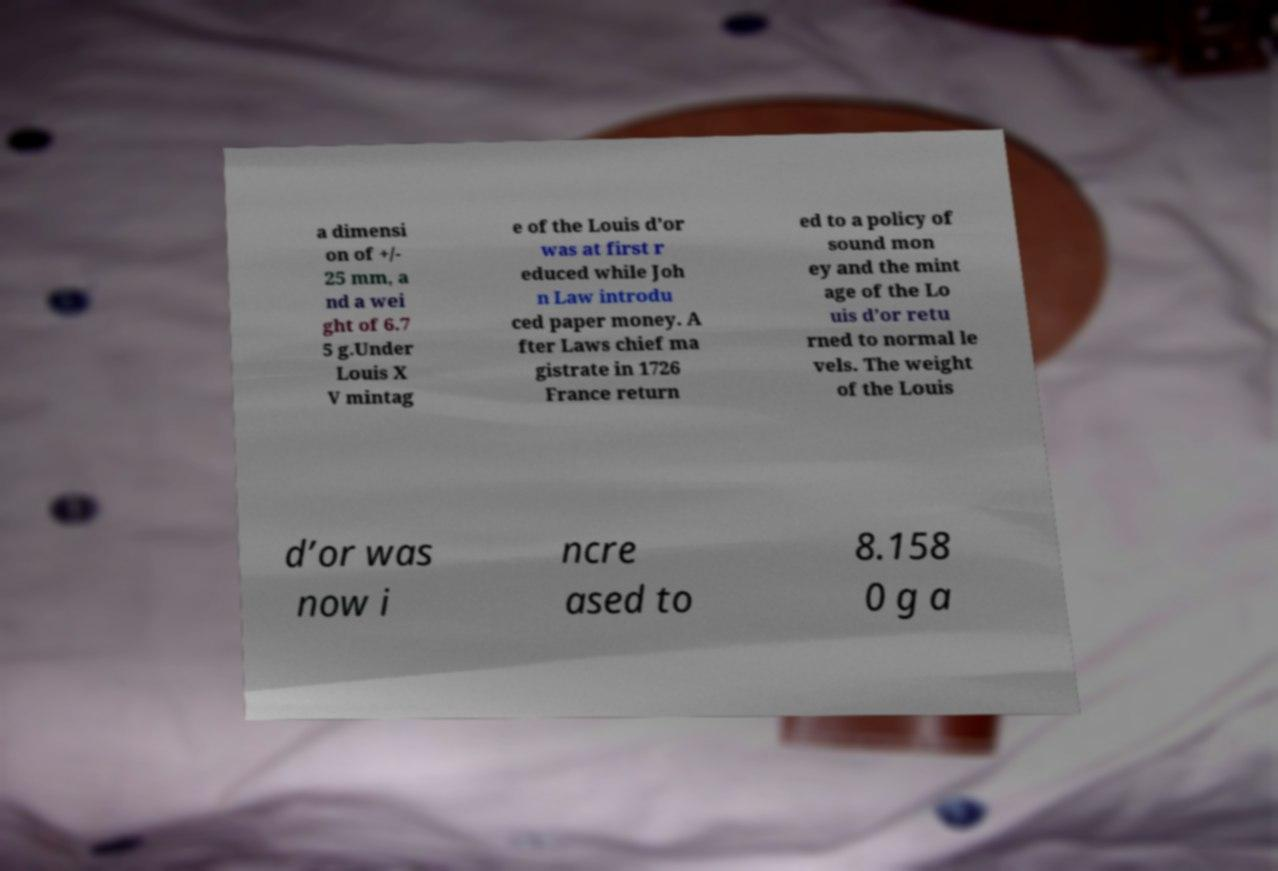Can you read and provide the text displayed in the image?This photo seems to have some interesting text. Can you extract and type it out for me? a dimensi on of +/- 25 mm, a nd a wei ght of 6.7 5 g.Under Louis X V mintag e of the Louis d’or was at first r educed while Joh n Law introdu ced paper money. A fter Laws chief ma gistrate in 1726 France return ed to a policy of sound mon ey and the mint age of the Lo uis d’or retu rned to normal le vels. The weight of the Louis d’or was now i ncre ased to 8.158 0 g a 